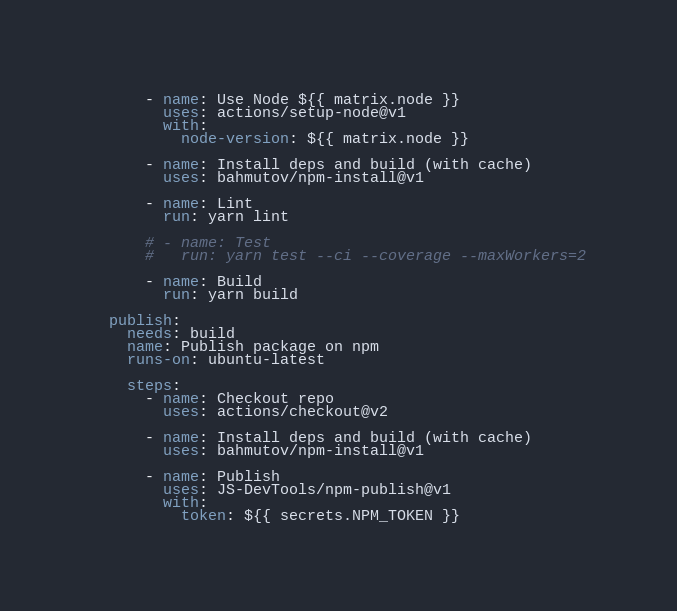<code> <loc_0><loc_0><loc_500><loc_500><_YAML_>      - name: Use Node ${{ matrix.node }}
        uses: actions/setup-node@v1
        with:
          node-version: ${{ matrix.node }}

      - name: Install deps and build (with cache)
        uses: bahmutov/npm-install@v1

      - name: Lint
        run: yarn lint

      # - name: Test
      #   run: yarn test --ci --coverage --maxWorkers=2

      - name: Build
        run: yarn build

  publish:
    needs: build
    name: Publish package on npm
    runs-on: ubuntu-latest

    steps:
      - name: Checkout repo
        uses: actions/checkout@v2
      
      - name: Install deps and build (with cache)
        uses: bahmutov/npm-install@v1

      - name: Publish
        uses: JS-DevTools/npm-publish@v1
        with:
          token: ${{ secrets.NPM_TOKEN }}</code> 